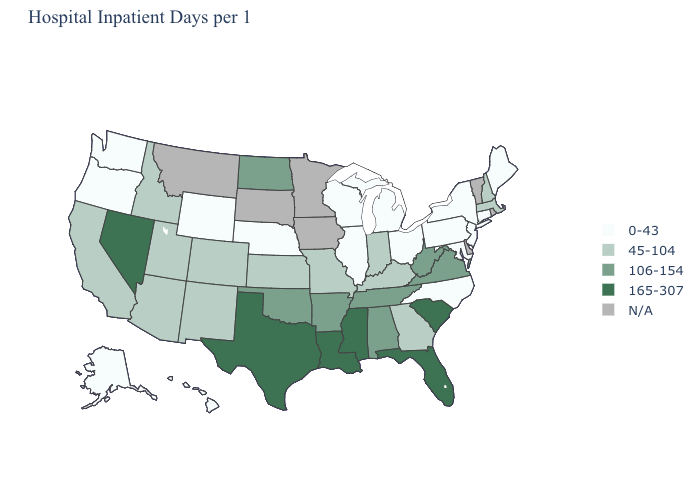Which states have the lowest value in the USA?
Quick response, please. Alaska, Connecticut, Hawaii, Illinois, Maine, Maryland, Michigan, Nebraska, New Jersey, New York, North Carolina, Ohio, Oregon, Pennsylvania, Washington, Wisconsin, Wyoming. Name the states that have a value in the range 45-104?
Be succinct. Arizona, California, Colorado, Georgia, Idaho, Indiana, Kansas, Kentucky, Massachusetts, Missouri, New Hampshire, New Mexico, Utah. Among the states that border Wyoming , which have the lowest value?
Write a very short answer. Nebraska. Name the states that have a value in the range N/A?
Write a very short answer. Delaware, Iowa, Minnesota, Montana, Rhode Island, South Dakota, Vermont. Among the states that border Indiana , which have the lowest value?
Answer briefly. Illinois, Michigan, Ohio. What is the value of Alaska?
Answer briefly. 0-43. Name the states that have a value in the range 165-307?
Short answer required. Florida, Louisiana, Mississippi, Nevada, South Carolina, Texas. What is the value of Wyoming?
Give a very brief answer. 0-43. How many symbols are there in the legend?
Concise answer only. 5. What is the highest value in states that border Arkansas?
Be succinct. 165-307. Name the states that have a value in the range 0-43?
Quick response, please. Alaska, Connecticut, Hawaii, Illinois, Maine, Maryland, Michigan, Nebraska, New Jersey, New York, North Carolina, Ohio, Oregon, Pennsylvania, Washington, Wisconsin, Wyoming. What is the value of Ohio?
Keep it brief. 0-43. What is the value of Florida?
Keep it brief. 165-307. What is the lowest value in the MidWest?
Write a very short answer. 0-43. Among the states that border Oklahoma , which have the lowest value?
Keep it brief. Colorado, Kansas, Missouri, New Mexico. 